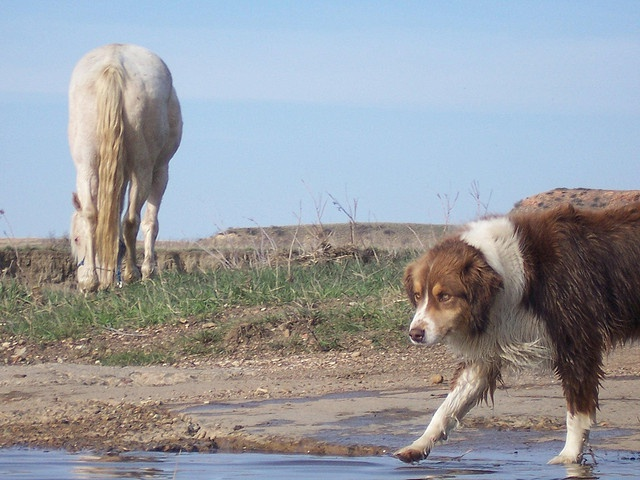Describe the objects in this image and their specific colors. I can see dog in lightblue, black, and gray tones and horse in lightblue, gray, lightgray, darkgray, and tan tones in this image. 